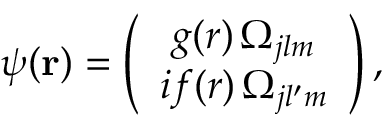Convert formula to latex. <formula><loc_0><loc_0><loc_500><loc_500>\psi ( r ) = \left ( \begin{array} { c } { g ( r ) \, \Omega _ { j l m } } \\ { i f ( r ) \, \Omega _ { j l ^ { \prime } m } } \end{array} \right ) ,</formula> 